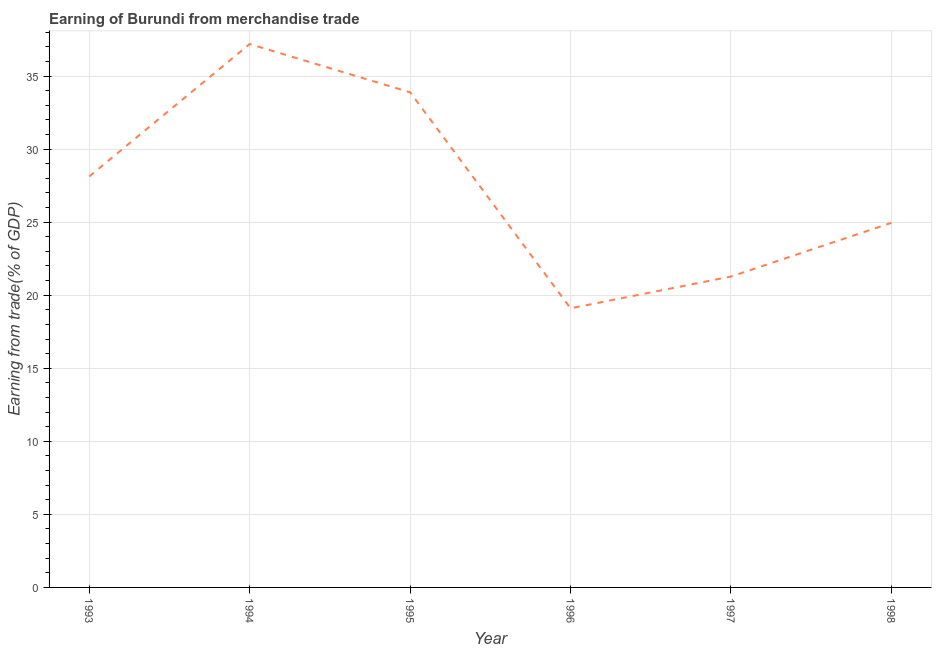What is the earning from merchandise trade in 1994?
Give a very brief answer. 37.19. Across all years, what is the maximum earning from merchandise trade?
Give a very brief answer. 37.19. Across all years, what is the minimum earning from merchandise trade?
Your answer should be compact. 19.1. In which year was the earning from merchandise trade maximum?
Give a very brief answer. 1994. What is the sum of the earning from merchandise trade?
Keep it short and to the point. 164.53. What is the difference between the earning from merchandise trade in 1996 and 1997?
Give a very brief answer. -2.18. What is the average earning from merchandise trade per year?
Offer a terse response. 27.42. What is the median earning from merchandise trade?
Your response must be concise. 26.54. What is the ratio of the earning from merchandise trade in 1996 to that in 1997?
Keep it short and to the point. 0.9. Is the earning from merchandise trade in 1994 less than that in 1998?
Your response must be concise. No. Is the difference between the earning from merchandise trade in 1994 and 1997 greater than the difference between any two years?
Make the answer very short. No. What is the difference between the highest and the second highest earning from merchandise trade?
Provide a succinct answer. 3.3. What is the difference between the highest and the lowest earning from merchandise trade?
Provide a short and direct response. 18.09. In how many years, is the earning from merchandise trade greater than the average earning from merchandise trade taken over all years?
Your response must be concise. 3. What is the difference between two consecutive major ticks on the Y-axis?
Offer a terse response. 5. Are the values on the major ticks of Y-axis written in scientific E-notation?
Keep it short and to the point. No. Does the graph contain grids?
Your answer should be compact. Yes. What is the title of the graph?
Provide a succinct answer. Earning of Burundi from merchandise trade. What is the label or title of the Y-axis?
Your answer should be very brief. Earning from trade(% of GDP). What is the Earning from trade(% of GDP) in 1993?
Provide a succinct answer. 28.13. What is the Earning from trade(% of GDP) in 1994?
Offer a very short reply. 37.19. What is the Earning from trade(% of GDP) of 1995?
Provide a succinct answer. 33.89. What is the Earning from trade(% of GDP) in 1996?
Give a very brief answer. 19.1. What is the Earning from trade(% of GDP) in 1997?
Offer a terse response. 21.28. What is the Earning from trade(% of GDP) in 1998?
Your answer should be very brief. 24.95. What is the difference between the Earning from trade(% of GDP) in 1993 and 1994?
Provide a short and direct response. -9.06. What is the difference between the Earning from trade(% of GDP) in 1993 and 1995?
Give a very brief answer. -5.76. What is the difference between the Earning from trade(% of GDP) in 1993 and 1996?
Provide a short and direct response. 9.02. What is the difference between the Earning from trade(% of GDP) in 1993 and 1997?
Ensure brevity in your answer.  6.85. What is the difference between the Earning from trade(% of GDP) in 1993 and 1998?
Keep it short and to the point. 3.18. What is the difference between the Earning from trade(% of GDP) in 1994 and 1995?
Make the answer very short. 3.3. What is the difference between the Earning from trade(% of GDP) in 1994 and 1996?
Provide a succinct answer. 18.09. What is the difference between the Earning from trade(% of GDP) in 1994 and 1997?
Make the answer very short. 15.91. What is the difference between the Earning from trade(% of GDP) in 1994 and 1998?
Your answer should be compact. 12.24. What is the difference between the Earning from trade(% of GDP) in 1995 and 1996?
Give a very brief answer. 14.78. What is the difference between the Earning from trade(% of GDP) in 1995 and 1997?
Make the answer very short. 12.61. What is the difference between the Earning from trade(% of GDP) in 1995 and 1998?
Your answer should be compact. 8.94. What is the difference between the Earning from trade(% of GDP) in 1996 and 1997?
Give a very brief answer. -2.17. What is the difference between the Earning from trade(% of GDP) in 1996 and 1998?
Your answer should be compact. -5.85. What is the difference between the Earning from trade(% of GDP) in 1997 and 1998?
Keep it short and to the point. -3.67. What is the ratio of the Earning from trade(% of GDP) in 1993 to that in 1994?
Offer a very short reply. 0.76. What is the ratio of the Earning from trade(% of GDP) in 1993 to that in 1995?
Your response must be concise. 0.83. What is the ratio of the Earning from trade(% of GDP) in 1993 to that in 1996?
Offer a terse response. 1.47. What is the ratio of the Earning from trade(% of GDP) in 1993 to that in 1997?
Provide a succinct answer. 1.32. What is the ratio of the Earning from trade(% of GDP) in 1993 to that in 1998?
Give a very brief answer. 1.13. What is the ratio of the Earning from trade(% of GDP) in 1994 to that in 1995?
Make the answer very short. 1.1. What is the ratio of the Earning from trade(% of GDP) in 1994 to that in 1996?
Your answer should be compact. 1.95. What is the ratio of the Earning from trade(% of GDP) in 1994 to that in 1997?
Make the answer very short. 1.75. What is the ratio of the Earning from trade(% of GDP) in 1994 to that in 1998?
Offer a terse response. 1.49. What is the ratio of the Earning from trade(% of GDP) in 1995 to that in 1996?
Your response must be concise. 1.77. What is the ratio of the Earning from trade(% of GDP) in 1995 to that in 1997?
Your answer should be very brief. 1.59. What is the ratio of the Earning from trade(% of GDP) in 1995 to that in 1998?
Your answer should be very brief. 1.36. What is the ratio of the Earning from trade(% of GDP) in 1996 to that in 1997?
Offer a very short reply. 0.9. What is the ratio of the Earning from trade(% of GDP) in 1996 to that in 1998?
Provide a short and direct response. 0.77. What is the ratio of the Earning from trade(% of GDP) in 1997 to that in 1998?
Ensure brevity in your answer.  0.85. 